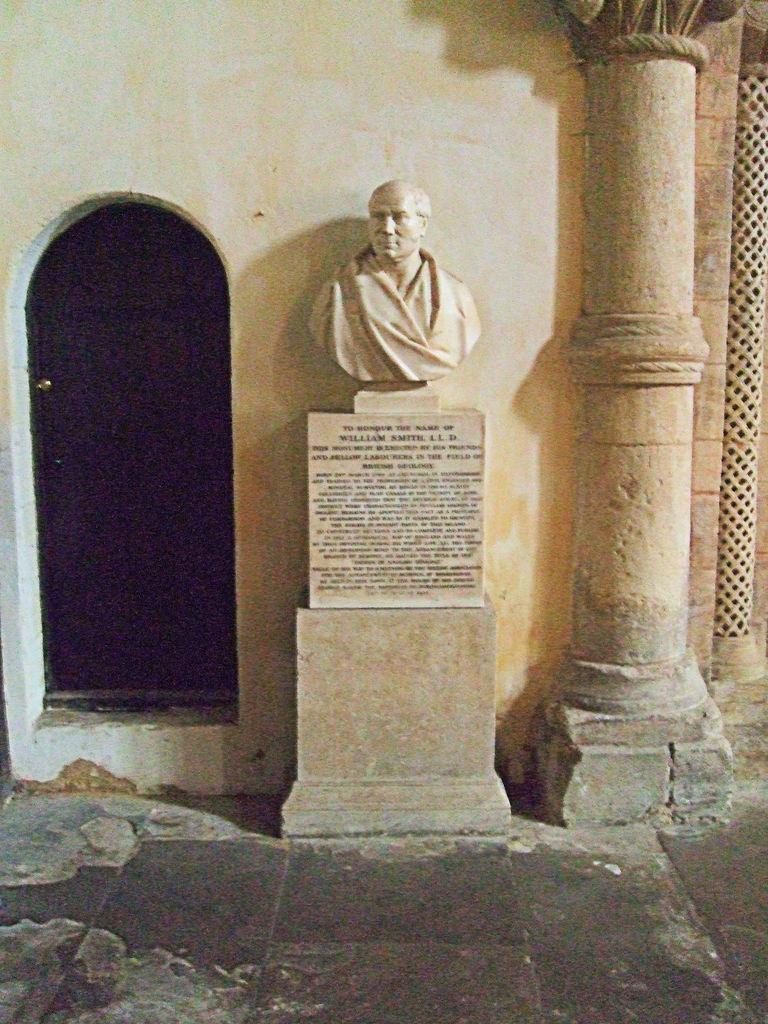What is the main subject in the image? There is a statue in the image. What else can be seen in the middle of the image? There is text in the middle of the image. Where is the door located in the image? There is a door on the left side of the image. What is present on the right side of the image? There is a pillar on the right side of the image. How many pages are visible in the image? There are no pages present in the image; it features a statue, text, a door, and a pillar. Can you see a flock of birds in the image? There is no flock of birds visible in the image. 